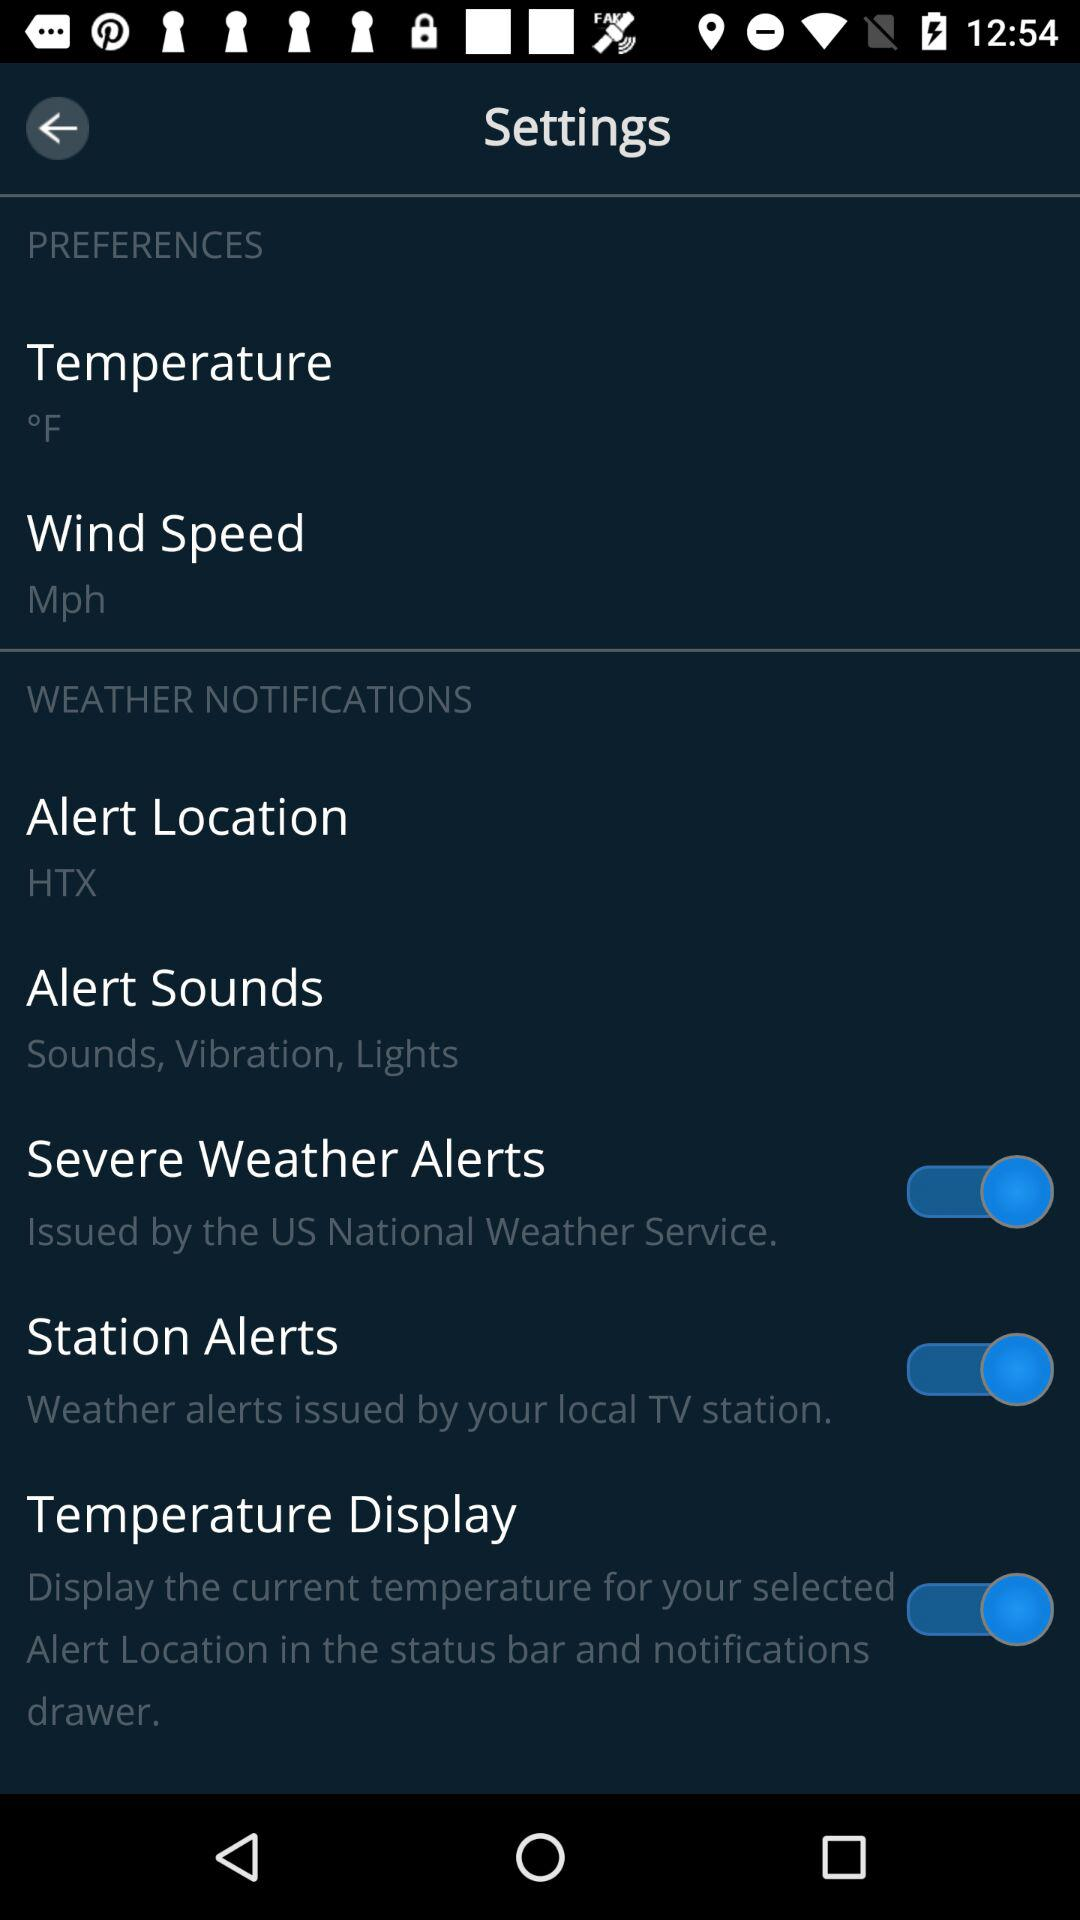How many of the preferences sections have a switch?
Answer the question using a single word or phrase. 3 